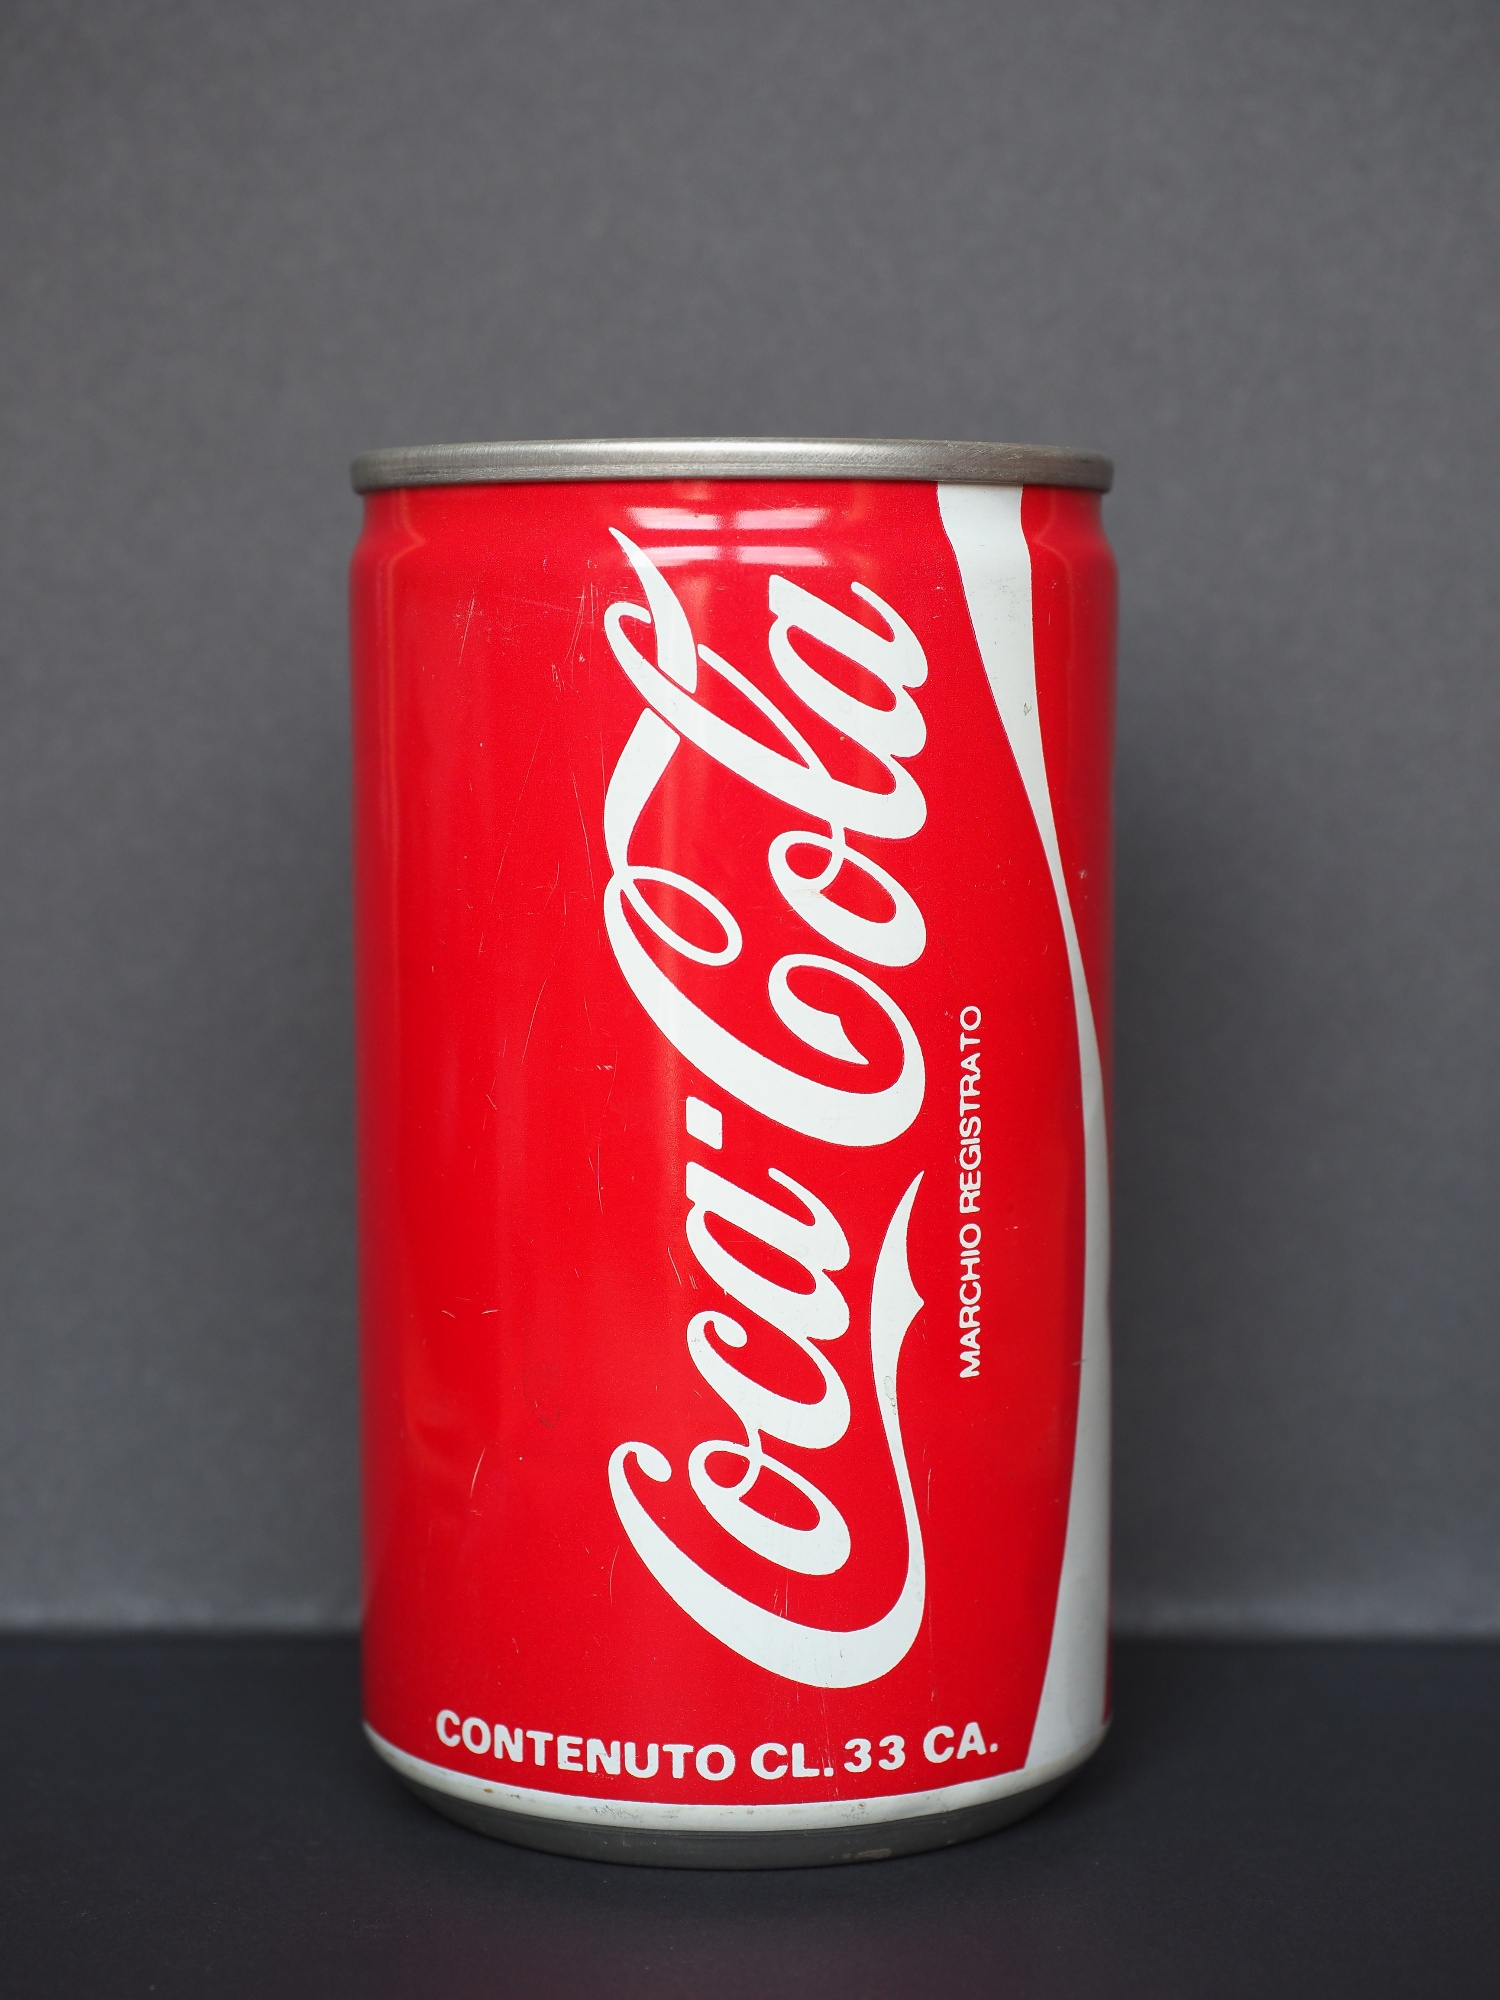Could you tell a realistic scenario related to this image in a short way? A cold Coca Cola can, fresh out of the fridge, ready to quench someone's thirst on a hot summer day. The person grabs it, feeling the cool metal under their fingers, and pops the tab to enjoy a refreshing break from the heat. 